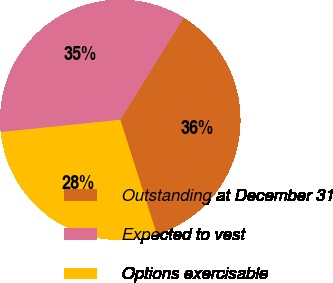Convert chart to OTSL. <chart><loc_0><loc_0><loc_500><loc_500><pie_chart><fcel>Outstanding at December 31<fcel>Expected to vest<fcel>Options exercisable<nl><fcel>36.25%<fcel>35.48%<fcel>28.28%<nl></chart> 